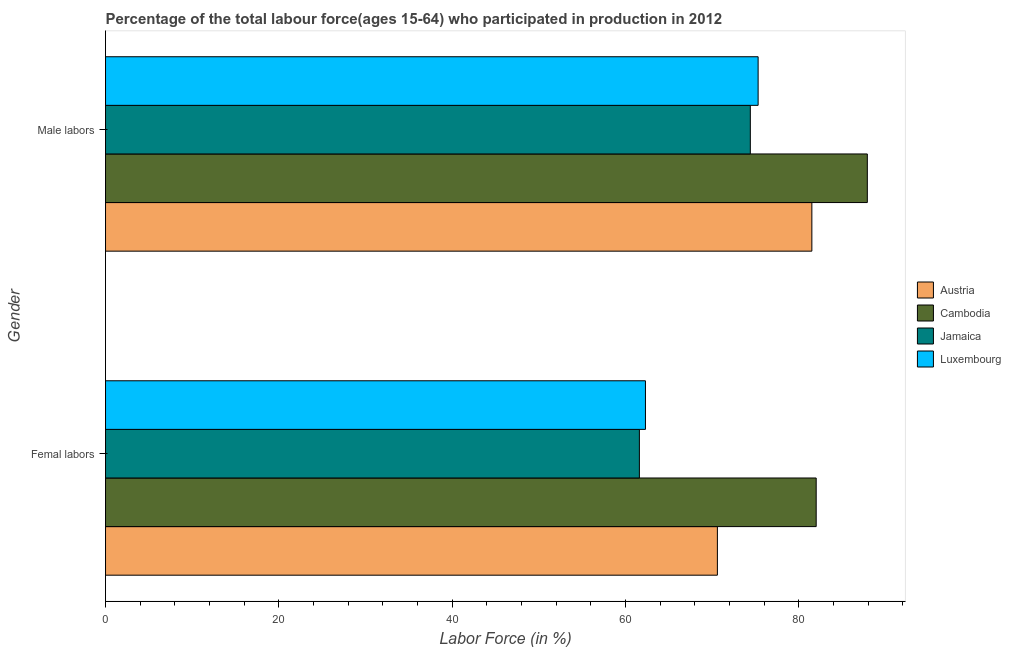How many different coloured bars are there?
Ensure brevity in your answer.  4. How many groups of bars are there?
Provide a succinct answer. 2. Are the number of bars per tick equal to the number of legend labels?
Offer a terse response. Yes. How many bars are there on the 2nd tick from the bottom?
Your response must be concise. 4. What is the label of the 1st group of bars from the top?
Keep it short and to the point. Male labors. What is the percentage of female labor force in Cambodia?
Your answer should be compact. 82. Across all countries, what is the minimum percentage of female labor force?
Offer a very short reply. 61.6. In which country was the percentage of female labor force maximum?
Give a very brief answer. Cambodia. In which country was the percentage of male labour force minimum?
Provide a short and direct response. Jamaica. What is the total percentage of female labor force in the graph?
Your answer should be very brief. 276.5. What is the difference between the percentage of male labour force in Cambodia and that in Luxembourg?
Provide a short and direct response. 12.6. What is the difference between the percentage of male labour force in Luxembourg and the percentage of female labor force in Austria?
Make the answer very short. 4.7. What is the average percentage of female labor force per country?
Your answer should be very brief. 69.12. What is the difference between the percentage of female labor force and percentage of male labour force in Jamaica?
Provide a succinct answer. -12.8. What is the ratio of the percentage of male labour force in Luxembourg to that in Austria?
Your answer should be compact. 0.92. Is the percentage of male labour force in Jamaica less than that in Cambodia?
Your answer should be very brief. Yes. What does the 4th bar from the top in Male labors represents?
Provide a succinct answer. Austria. What does the 4th bar from the bottom in Male labors represents?
Ensure brevity in your answer.  Luxembourg. What is the difference between two consecutive major ticks on the X-axis?
Offer a terse response. 20. Are the values on the major ticks of X-axis written in scientific E-notation?
Offer a terse response. No. Where does the legend appear in the graph?
Offer a very short reply. Center right. How many legend labels are there?
Offer a terse response. 4. How are the legend labels stacked?
Keep it short and to the point. Vertical. What is the title of the graph?
Keep it short and to the point. Percentage of the total labour force(ages 15-64) who participated in production in 2012. Does "Cyprus" appear as one of the legend labels in the graph?
Your answer should be very brief. No. What is the label or title of the X-axis?
Your answer should be compact. Labor Force (in %). What is the Labor Force (in %) in Austria in Femal labors?
Your answer should be very brief. 70.6. What is the Labor Force (in %) in Jamaica in Femal labors?
Your answer should be compact. 61.6. What is the Labor Force (in %) in Luxembourg in Femal labors?
Make the answer very short. 62.3. What is the Labor Force (in %) of Austria in Male labors?
Keep it short and to the point. 81.5. What is the Labor Force (in %) of Cambodia in Male labors?
Give a very brief answer. 87.9. What is the Labor Force (in %) of Jamaica in Male labors?
Ensure brevity in your answer.  74.4. What is the Labor Force (in %) of Luxembourg in Male labors?
Offer a very short reply. 75.3. Across all Gender, what is the maximum Labor Force (in %) in Austria?
Ensure brevity in your answer.  81.5. Across all Gender, what is the maximum Labor Force (in %) in Cambodia?
Make the answer very short. 87.9. Across all Gender, what is the maximum Labor Force (in %) of Jamaica?
Your response must be concise. 74.4. Across all Gender, what is the maximum Labor Force (in %) in Luxembourg?
Provide a succinct answer. 75.3. Across all Gender, what is the minimum Labor Force (in %) of Austria?
Provide a short and direct response. 70.6. Across all Gender, what is the minimum Labor Force (in %) in Cambodia?
Your answer should be compact. 82. Across all Gender, what is the minimum Labor Force (in %) in Jamaica?
Make the answer very short. 61.6. Across all Gender, what is the minimum Labor Force (in %) of Luxembourg?
Offer a very short reply. 62.3. What is the total Labor Force (in %) of Austria in the graph?
Give a very brief answer. 152.1. What is the total Labor Force (in %) in Cambodia in the graph?
Keep it short and to the point. 169.9. What is the total Labor Force (in %) in Jamaica in the graph?
Your response must be concise. 136. What is the total Labor Force (in %) in Luxembourg in the graph?
Keep it short and to the point. 137.6. What is the difference between the Labor Force (in %) of Cambodia in Femal labors and that in Male labors?
Make the answer very short. -5.9. What is the difference between the Labor Force (in %) of Austria in Femal labors and the Labor Force (in %) of Cambodia in Male labors?
Give a very brief answer. -17.3. What is the difference between the Labor Force (in %) in Austria in Femal labors and the Labor Force (in %) in Jamaica in Male labors?
Keep it short and to the point. -3.8. What is the difference between the Labor Force (in %) of Cambodia in Femal labors and the Labor Force (in %) of Luxembourg in Male labors?
Your response must be concise. 6.7. What is the difference between the Labor Force (in %) of Jamaica in Femal labors and the Labor Force (in %) of Luxembourg in Male labors?
Your answer should be compact. -13.7. What is the average Labor Force (in %) of Austria per Gender?
Your response must be concise. 76.05. What is the average Labor Force (in %) of Cambodia per Gender?
Your response must be concise. 84.95. What is the average Labor Force (in %) in Luxembourg per Gender?
Give a very brief answer. 68.8. What is the difference between the Labor Force (in %) in Austria and Labor Force (in %) in Jamaica in Femal labors?
Ensure brevity in your answer.  9. What is the difference between the Labor Force (in %) of Austria and Labor Force (in %) of Luxembourg in Femal labors?
Offer a very short reply. 8.3. What is the difference between the Labor Force (in %) in Cambodia and Labor Force (in %) in Jamaica in Femal labors?
Give a very brief answer. 20.4. What is the difference between the Labor Force (in %) of Cambodia and Labor Force (in %) of Luxembourg in Femal labors?
Provide a short and direct response. 19.7. What is the difference between the Labor Force (in %) in Cambodia and Labor Force (in %) in Jamaica in Male labors?
Give a very brief answer. 13.5. What is the ratio of the Labor Force (in %) in Austria in Femal labors to that in Male labors?
Provide a short and direct response. 0.87. What is the ratio of the Labor Force (in %) in Cambodia in Femal labors to that in Male labors?
Make the answer very short. 0.93. What is the ratio of the Labor Force (in %) of Jamaica in Femal labors to that in Male labors?
Keep it short and to the point. 0.83. What is the ratio of the Labor Force (in %) of Luxembourg in Femal labors to that in Male labors?
Provide a short and direct response. 0.83. What is the difference between the highest and the second highest Labor Force (in %) of Cambodia?
Offer a terse response. 5.9. What is the difference between the highest and the second highest Labor Force (in %) of Jamaica?
Make the answer very short. 12.8. What is the difference between the highest and the second highest Labor Force (in %) of Luxembourg?
Your response must be concise. 13. 